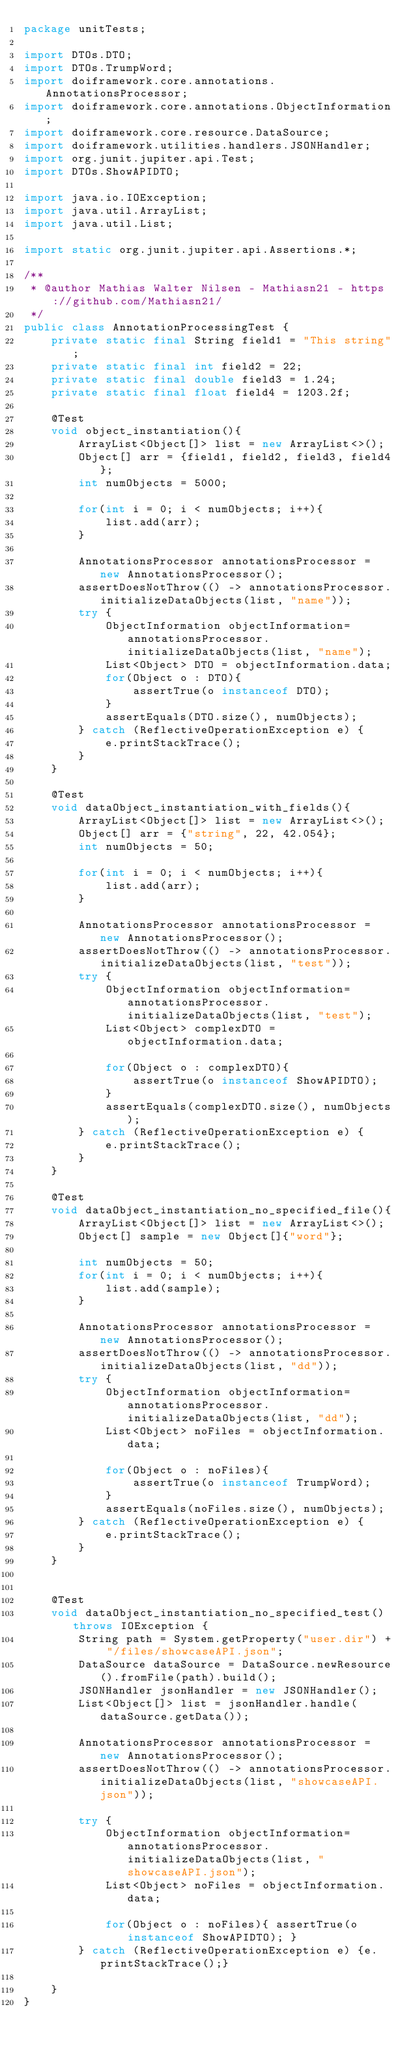<code> <loc_0><loc_0><loc_500><loc_500><_Java_>package unitTests;

import DTOs.DTO;
import DTOs.TrumpWord;
import doiframework.core.annotations.AnnotationsProcessor;
import doiframework.core.annotations.ObjectInformation;
import doiframework.core.resource.DataSource;
import doiframework.utilities.handlers.JSONHandler;
import org.junit.jupiter.api.Test;
import DTOs.ShowAPIDTO;

import java.io.IOException;
import java.util.ArrayList;
import java.util.List;

import static org.junit.jupiter.api.Assertions.*;

/**
 * @author Mathias Walter Nilsen - Mathiasn21 - https://github.com/Mathiasn21/
 */
public class AnnotationProcessingTest {
    private static final String field1 = "This string";
    private static final int field2 = 22;
    private static final double field3 = 1.24;
    private static final float field4 = 1203.2f;

    @Test
    void object_instantiation(){
        ArrayList<Object[]> list = new ArrayList<>();
        Object[] arr = {field1, field2, field3, field4};
        int numObjects = 5000;

        for(int i = 0; i < numObjects; i++){
            list.add(arr);
        }

        AnnotationsProcessor annotationsProcessor = new AnnotationsProcessor();
        assertDoesNotThrow(() -> annotationsProcessor.initializeDataObjects(list, "name"));
        try {
            ObjectInformation objectInformation= annotationsProcessor.initializeDataObjects(list, "name");
            List<Object> DTO = objectInformation.data;
            for(Object o : DTO){
                assertTrue(o instanceof DTO);
            }
            assertEquals(DTO.size(), numObjects);
        } catch (ReflectiveOperationException e) {
            e.printStackTrace();
        }
    }

    @Test
    void dataObject_instantiation_with_fields(){
        ArrayList<Object[]> list = new ArrayList<>();
        Object[] arr = {"string", 22, 42.054};
        int numObjects = 50;

        for(int i = 0; i < numObjects; i++){
            list.add(arr);
        }

        AnnotationsProcessor annotationsProcessor = new AnnotationsProcessor();
        assertDoesNotThrow(() -> annotationsProcessor.initializeDataObjects(list, "test"));
        try {
            ObjectInformation objectInformation= annotationsProcessor.initializeDataObjects(list, "test");
            List<Object> complexDTO = objectInformation.data;

            for(Object o : complexDTO){
                assertTrue(o instanceof ShowAPIDTO);
            }
            assertEquals(complexDTO.size(), numObjects);
        } catch (ReflectiveOperationException e) {
            e.printStackTrace();
        }
    }

    @Test
    void dataObject_instantiation_no_specified_file(){
        ArrayList<Object[]> list = new ArrayList<>();
        Object[] sample = new Object[]{"word"};

        int numObjects = 50;
        for(int i = 0; i < numObjects; i++){
            list.add(sample);
        }

        AnnotationsProcessor annotationsProcessor = new AnnotationsProcessor();
        assertDoesNotThrow(() -> annotationsProcessor.initializeDataObjects(list, "dd"));
        try {
            ObjectInformation objectInformation= annotationsProcessor.initializeDataObjects(list, "dd");
            List<Object> noFiles = objectInformation.data;

            for(Object o : noFiles){
                assertTrue(o instanceof TrumpWord);
            }
            assertEquals(noFiles.size(), numObjects);
        } catch (ReflectiveOperationException e) {
            e.printStackTrace();
        }
    }


    @Test
    void dataObject_instantiation_no_specified_test() throws IOException {
        String path = System.getProperty("user.dir") + "/files/showcaseAPI.json";
        DataSource dataSource = DataSource.newResource().fromFile(path).build();
        JSONHandler jsonHandler = new JSONHandler();
        List<Object[]> list = jsonHandler.handle(dataSource.getData());

        AnnotationsProcessor annotationsProcessor = new AnnotationsProcessor();
        assertDoesNotThrow(() -> annotationsProcessor.initializeDataObjects(list, "showcaseAPI.json"));

        try {
            ObjectInformation objectInformation= annotationsProcessor.initializeDataObjects(list, "showcaseAPI.json");
            List<Object> noFiles = objectInformation.data;

            for(Object o : noFiles){ assertTrue(o instanceof ShowAPIDTO); }
        } catch (ReflectiveOperationException e) {e.printStackTrace();}

    }
}
</code> 